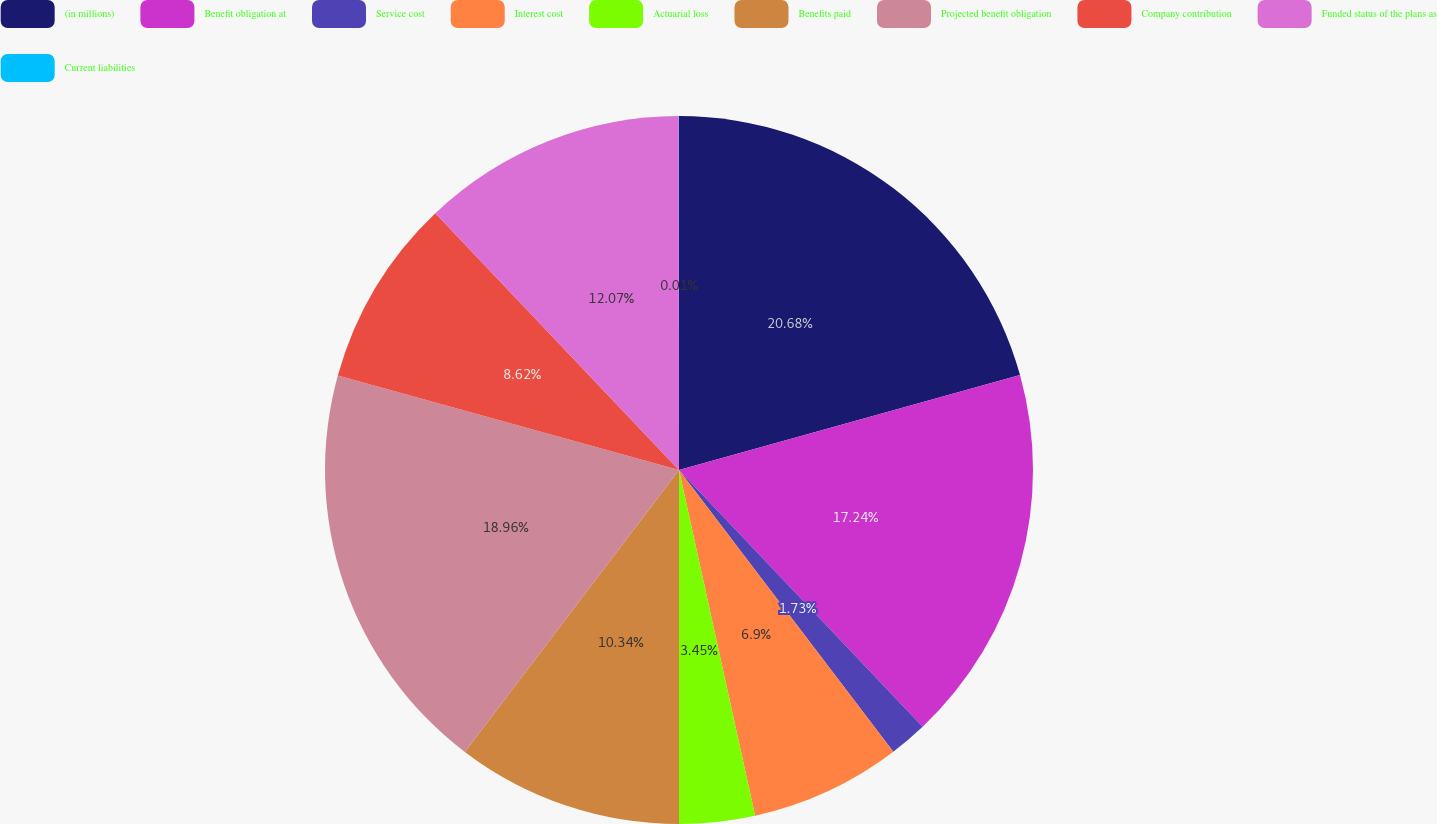Convert chart. <chart><loc_0><loc_0><loc_500><loc_500><pie_chart><fcel>(in millions)<fcel>Benefit obligation at<fcel>Service cost<fcel>Interest cost<fcel>Actuarial loss<fcel>Benefits paid<fcel>Projected benefit obligation<fcel>Company contribution<fcel>Funded status of the plans as<fcel>Current liabilities<nl><fcel>20.68%<fcel>17.24%<fcel>1.73%<fcel>6.9%<fcel>3.45%<fcel>10.34%<fcel>18.96%<fcel>8.62%<fcel>12.07%<fcel>0.01%<nl></chart> 